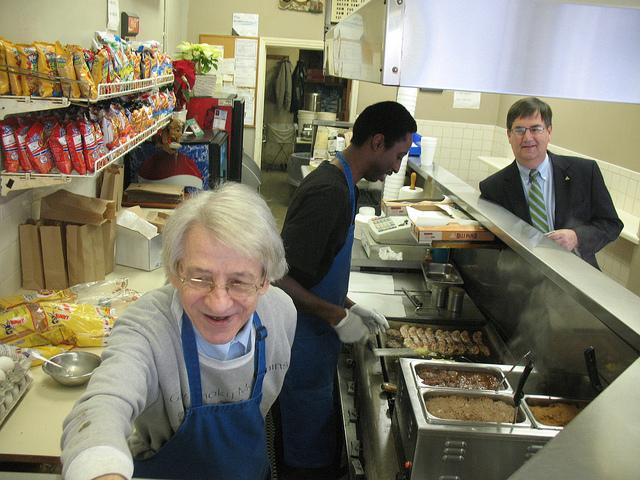Is this kitchen in an apartment?
Short answer required. No. Are the people happy?
Keep it brief. Yes. What is roasting in the oven behind the people?
Answer briefly. Not sure. What color is the apron?
Answer briefly. Blue. Is this a bakery?
Keep it brief. No. Is anyone wearing tuxedo's?
Answer briefly. No. What kind of jacket is the customer wearing?
Keep it brief. Suit jacket. 